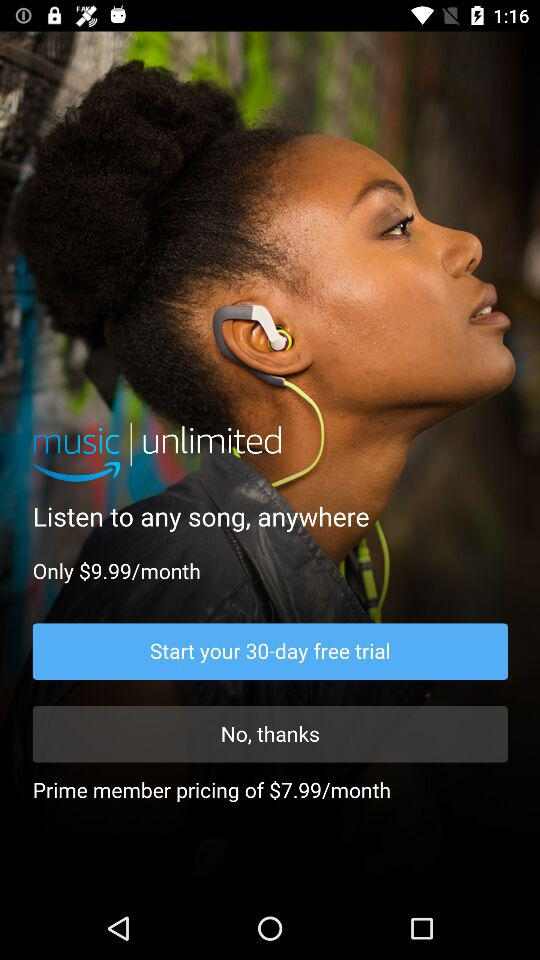What is the subscription price for Prime members for a month? The subscription price is $7.99 per month. 